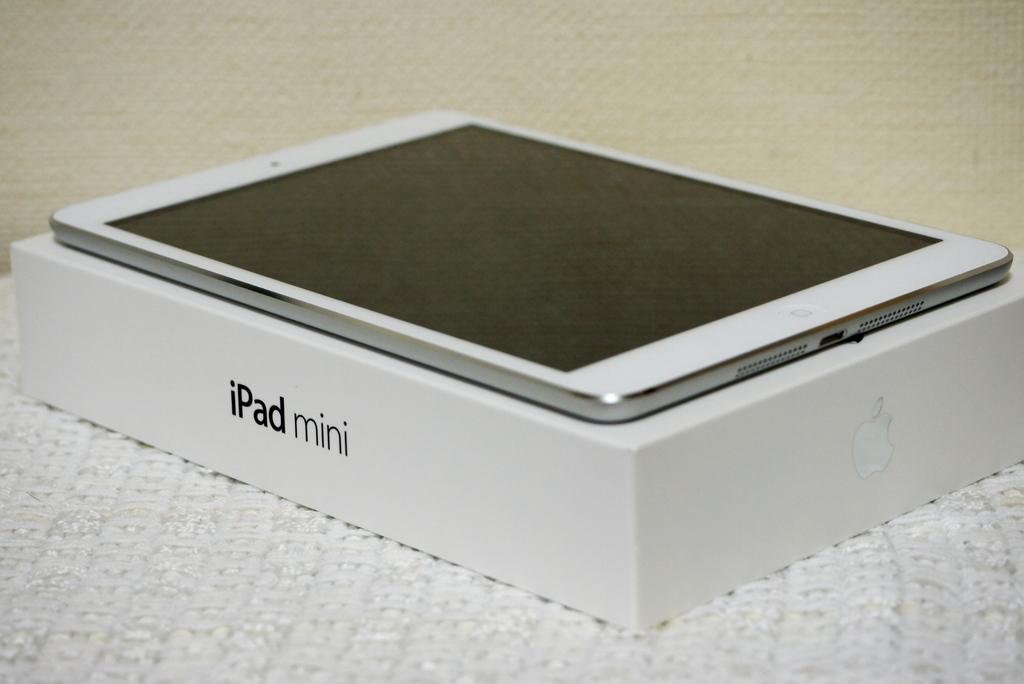Provide a one-sentence caption for the provided image. A box for an iPad mini has one on top of it. 